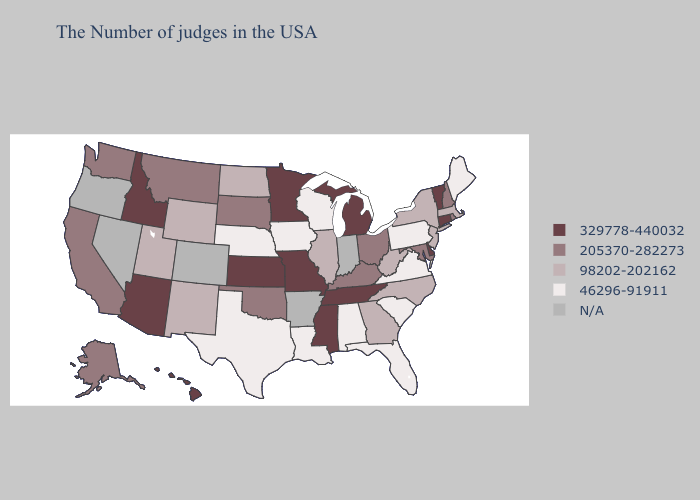Which states have the lowest value in the Northeast?
Write a very short answer. Maine, Pennsylvania. Does Idaho have the lowest value in the USA?
Answer briefly. No. What is the lowest value in the Northeast?
Answer briefly. 46296-91911. Among the states that border West Virginia , which have the lowest value?
Concise answer only. Pennsylvania, Virginia. Name the states that have a value in the range 46296-91911?
Keep it brief. Maine, Pennsylvania, Virginia, South Carolina, Florida, Alabama, Wisconsin, Louisiana, Iowa, Nebraska, Texas. Name the states that have a value in the range 46296-91911?
Short answer required. Maine, Pennsylvania, Virginia, South Carolina, Florida, Alabama, Wisconsin, Louisiana, Iowa, Nebraska, Texas. Which states hav the highest value in the Northeast?
Concise answer only. Vermont, Connecticut. Among the states that border Oklahoma , does Missouri have the highest value?
Answer briefly. Yes. Name the states that have a value in the range 205370-282273?
Answer briefly. Rhode Island, New Hampshire, Maryland, Ohio, Kentucky, Oklahoma, South Dakota, Montana, California, Washington, Alaska. Which states hav the highest value in the South?
Concise answer only. Delaware, Tennessee, Mississippi. What is the lowest value in states that border Kentucky?
Give a very brief answer. 46296-91911. Name the states that have a value in the range 98202-202162?
Concise answer only. Massachusetts, New York, New Jersey, North Carolina, West Virginia, Georgia, Illinois, North Dakota, Wyoming, New Mexico, Utah. 